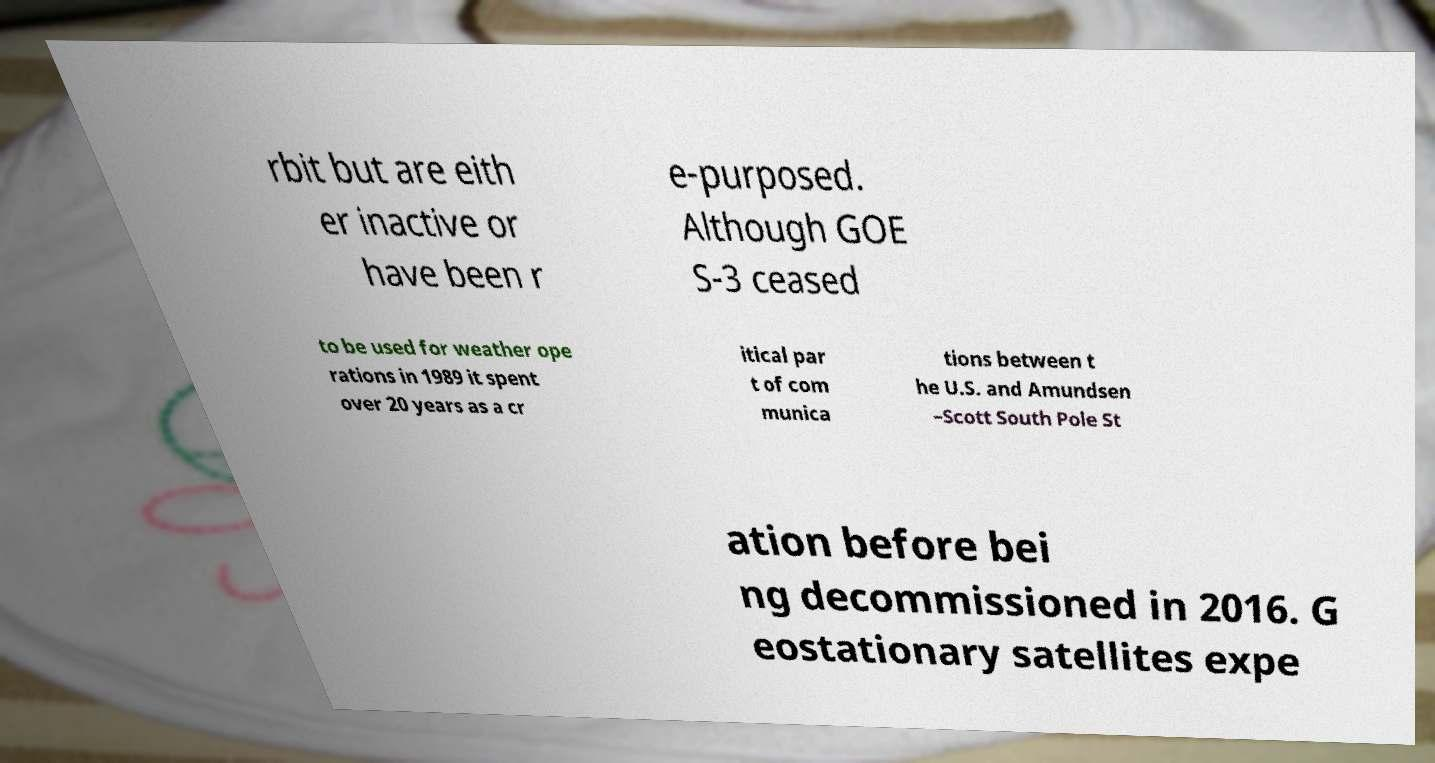Can you read and provide the text displayed in the image?This photo seems to have some interesting text. Can you extract and type it out for me? rbit but are eith er inactive or have been r e-purposed. Although GOE S-3 ceased to be used for weather ope rations in 1989 it spent over 20 years as a cr itical par t of com munica tions between t he U.S. and Amundsen –Scott South Pole St ation before bei ng decommissioned in 2016. G eostationary satellites expe 